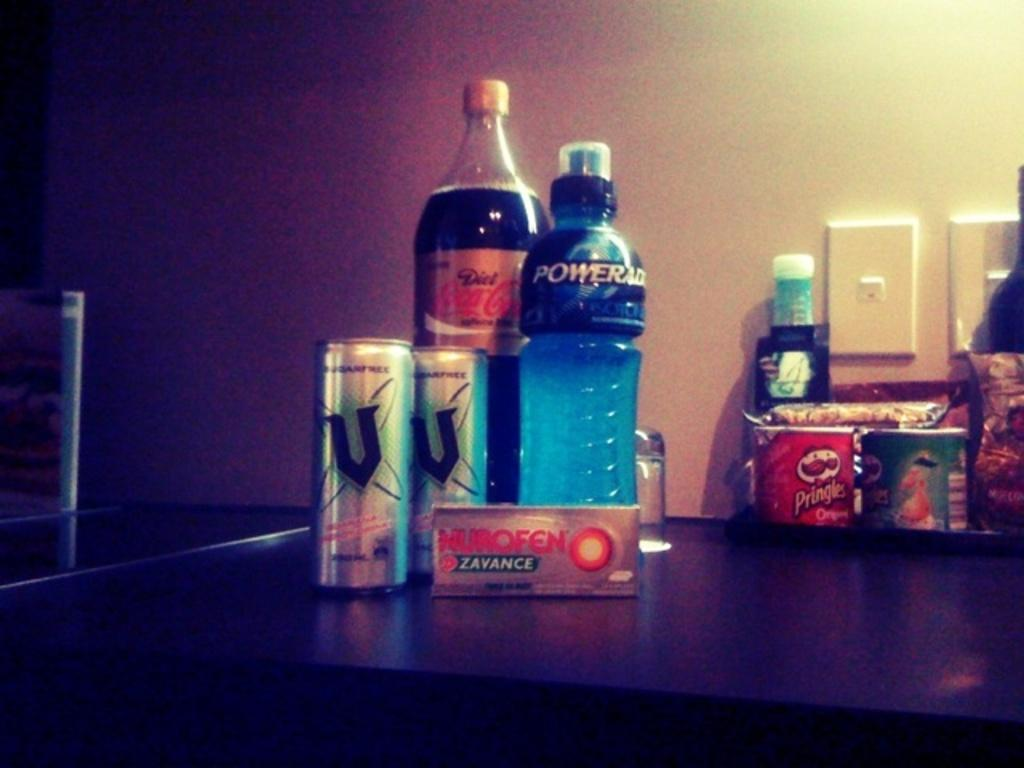<image>
Relay a brief, clear account of the picture shown. A collection of snacks and beverages include Pringles and Poweraid. 